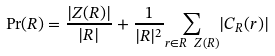<formula> <loc_0><loc_0><loc_500><loc_500>\Pr ( R ) = \frac { | Z ( R ) | } { | R | } + \frac { 1 } { | R | ^ { 2 } } \underset { r \in R \ Z ( R ) } { \sum } | C _ { R } ( r ) |</formula> 